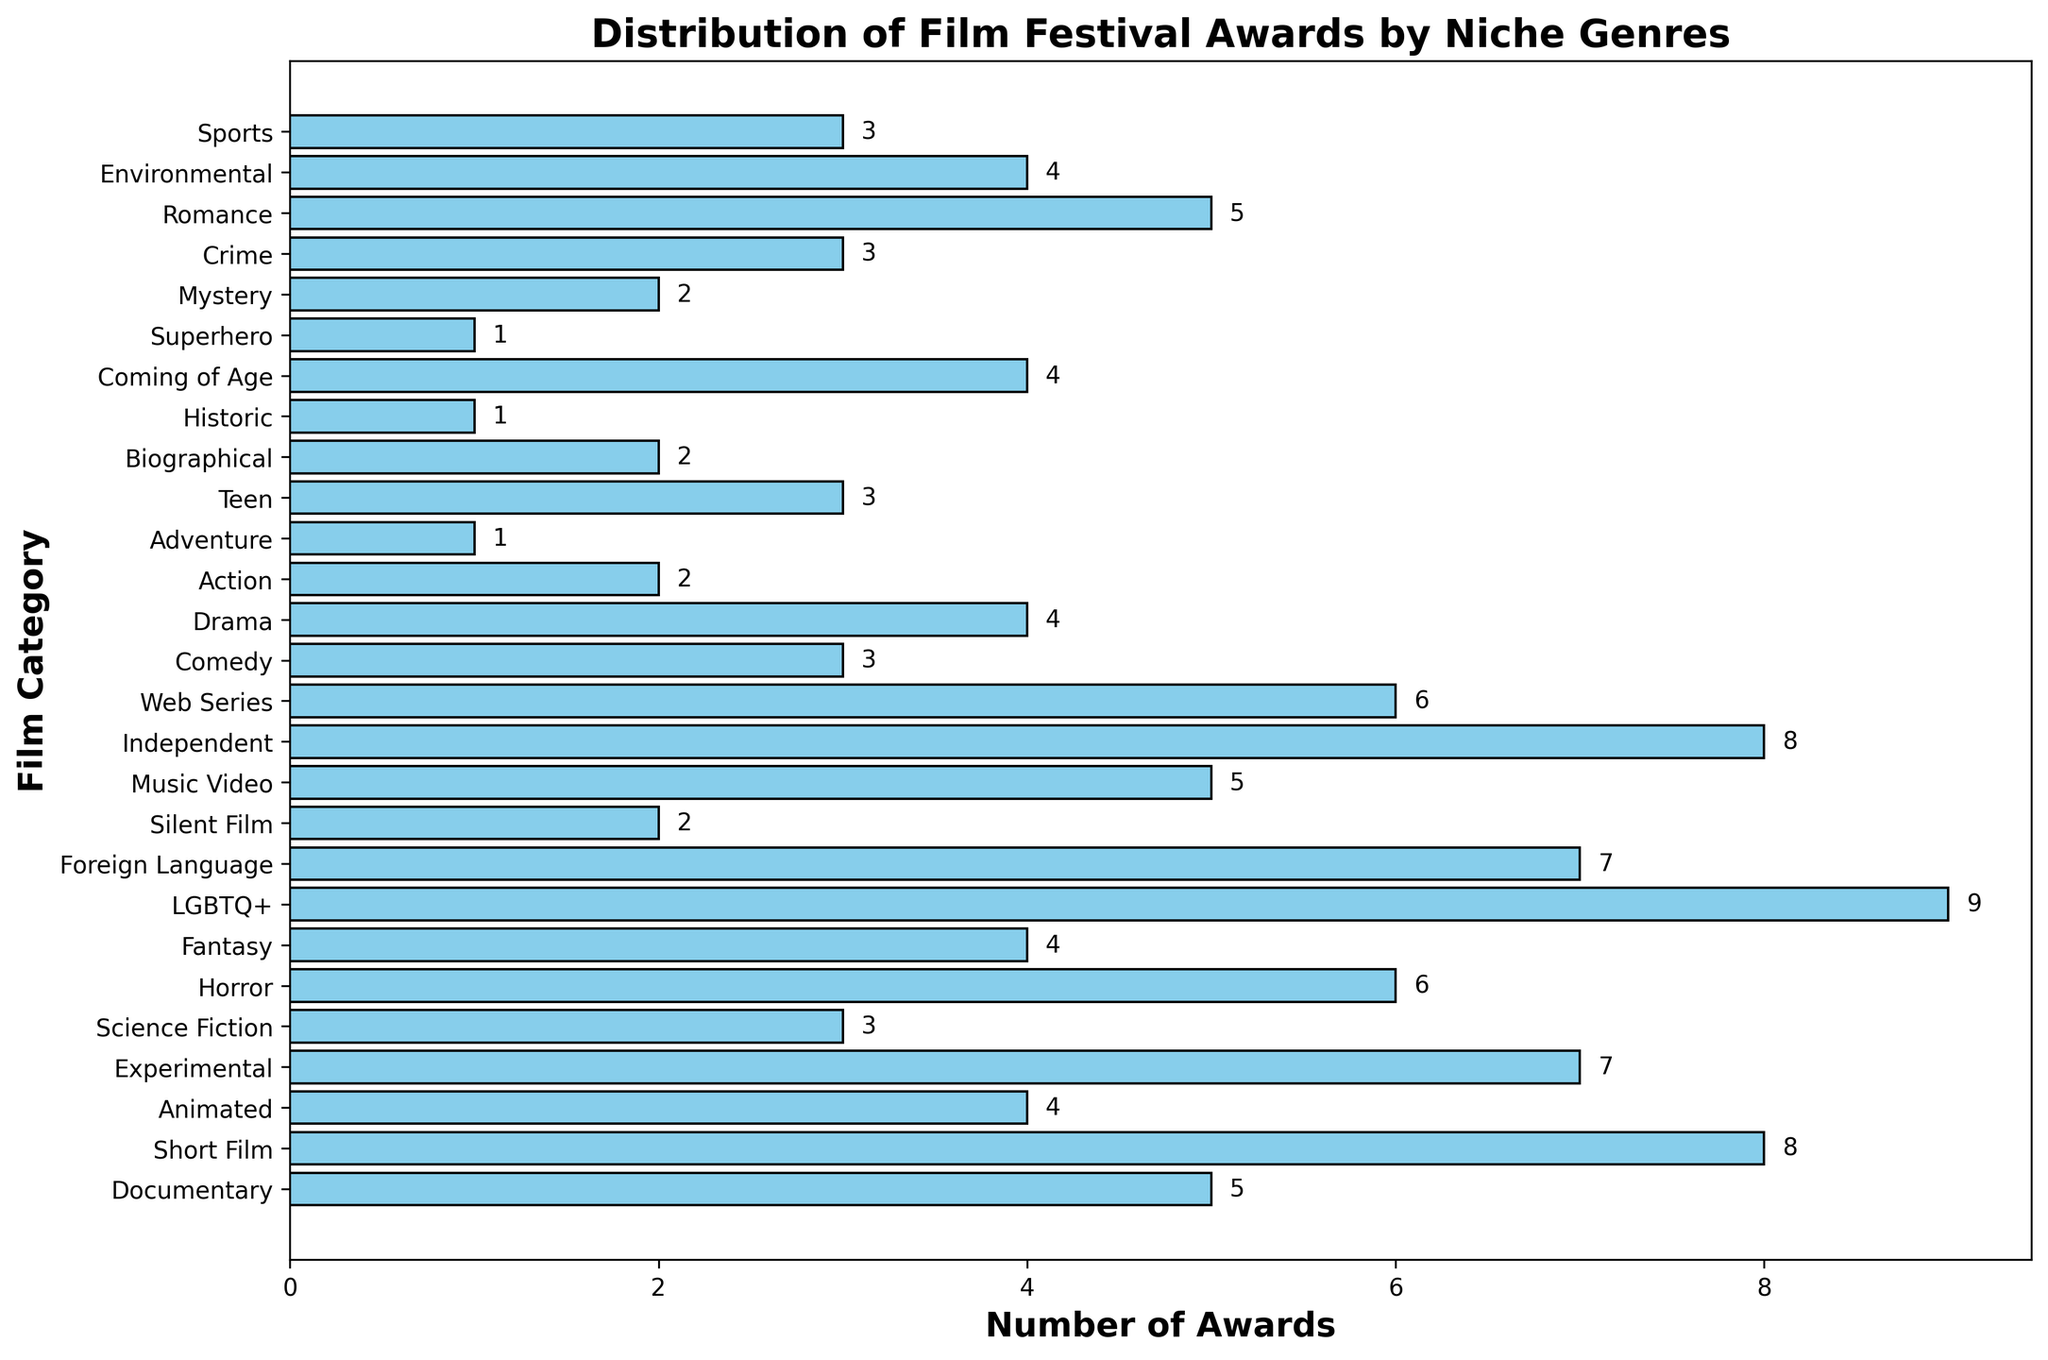Which category has won the most awards? By looking at the height of the bars, we can see that the LGBTQ+ category has the highest bar, indicating it has the most awards.
Answer: LGBTQ+ How many categories have won exactly 4 awards? We need to count the number of bars that have a height of 4. There are five such categories: Animated, Fantasy, Drama, Coming of Age, and Environmental.
Answer: 5 What's the total number of awards won by the Documentary and Horror categories? Add the awards count for the Documentary category (5) and the Horror category (6): 5 + 6 = 11.
Answer: 11 Which category has won more awards: Experimental or Foreign Language? Compare the heights of the bars for Experimental (7) and Foreign Language (7). Both categories have won the same number of awards.
Answer: Both have won 7 awards How many more awards has the Short Film category won compared to the Science Fiction category? Subtract the awards count of the Science Fiction category (3) from that of the Short Film category (8): 8 - 3 = 5.
Answer: 5 What is the average number of awards won by the Adventure, Superhero, and Historic categories? Add the awards counts for these categories: 1 (Adventure) + 1 (Superhero) + 1 (Historic) = 3. Then, divide by the number of categories, which is 3: 3 / 3 = 1.
Answer: 1 Which categories have won fewer awards than the Music Video category? The Music Video category has won 5 awards. The categories that have fewer awards are Science Fiction (3), Silent Film (2), Comedy (3), Action (2), Adventure (1), Teen (3), Biographical (2), Historic (1), Superhero (1), Mystery (2), and Crime (3).
Answer: 11 categories Is the number of awards won by the Independent category greater than the sum of awards won by the Teen and Crime categories? The Independent category has won 8 awards. The sum of Teen (3) and Crime (3) is 6. Since 8 (Independent) > 6 (Teen + Crime), the Independent category has won more awards.
Answer: Yes What's the median number of awards won by all categories? First, list the awards counts in ascending order: 1, 1, 1, 2, 2, 2, 3, 3, 3, 3, 3, 4, 4, 4, 4, 4, 5, 5, 5, 6, 6, 7, 7, 8, 8, 9. The median is the middle value in this ordered list, which is (4 + 4)/2 = 4 since there are 27 categories.
Answer: 4 